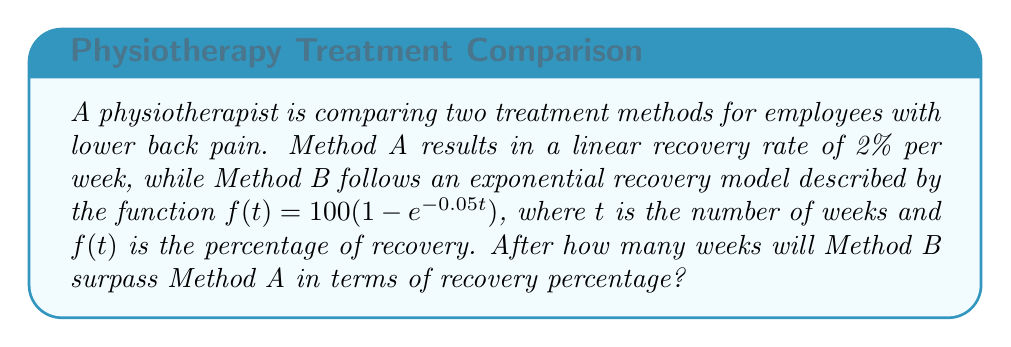Help me with this question. To solve this problem, we need to find the point where the recovery percentages of both methods are equal, and then determine when Method B exceeds Method A.

1. Express Method A's recovery percentage as a function of time:
   $A(t) = 2t$, where $t$ is the number of weeks.

2. Set up an equation where both methods are equal:
   $2t = 100(1 - e^{-0.05t})$

3. This equation cannot be solved algebraically, so we need to use numerical methods or graphing to find the solution.

4. Using a graphing calculator or software, we can plot both functions:
   $y = 2t$
   $y = 100(1 - e^{-0.05t})$

5. The intersection point occurs at approximately $t = 14.4$ weeks.

6. Since we need to determine when Method B surpasses Method A, we round up to the next whole number of weeks.

7. At 15 weeks:
   Method A: $A(15) = 2 * 15 = 30\%$
   Method B: $f(15) = 100(1 - e^{-0.05*15}) \approx 52.76\%$

8. Verify that at 14 weeks, Method A is still ahead:
   Method A: $A(14) = 2 * 14 = 28\%$
   Method B: $f(14) = 100(1 - e^{-0.05*14}) \approx 50.34\%$

Therefore, Method B surpasses Method A after 15 weeks of treatment.
Answer: 15 weeks 